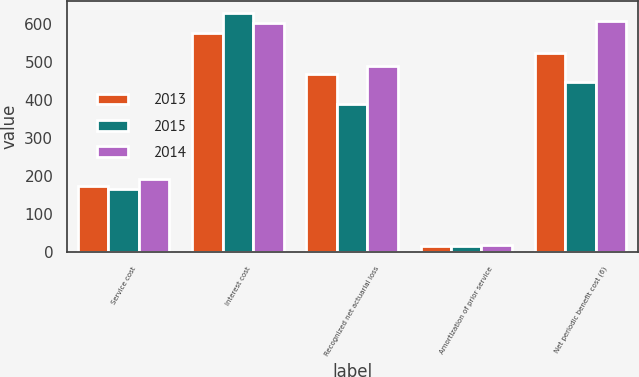Convert chart to OTSL. <chart><loc_0><loc_0><loc_500><loc_500><stacked_bar_chart><ecel><fcel>Service cost<fcel>Interest cost<fcel>Recognized net actuarial loss<fcel>Amortization of prior service<fcel>Net periodic benefit cost (6)<nl><fcel>2013<fcel>175<fcel>577<fcel>468<fcel>16<fcel>524<nl><fcel>2015<fcel>166<fcel>630<fcel>391<fcel>18<fcel>449<nl><fcel>2014<fcel>194<fcel>602<fcel>489<fcel>19<fcel>608<nl></chart> 